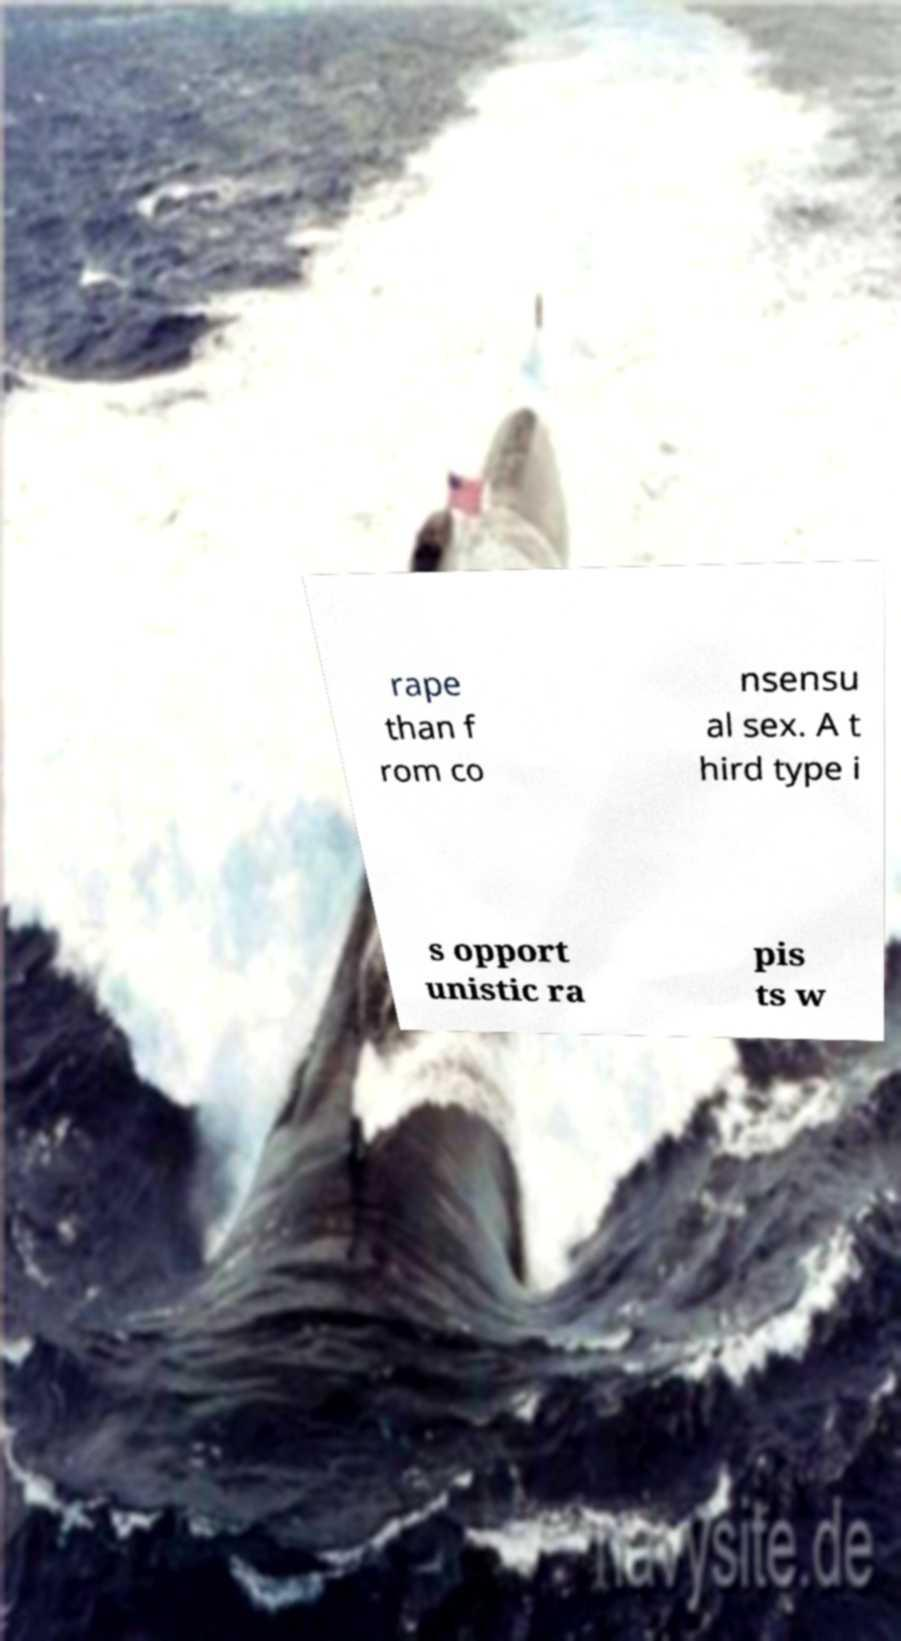What messages or text are displayed in this image? I need them in a readable, typed format. rape than f rom co nsensu al sex. A t hird type i s opport unistic ra pis ts w 